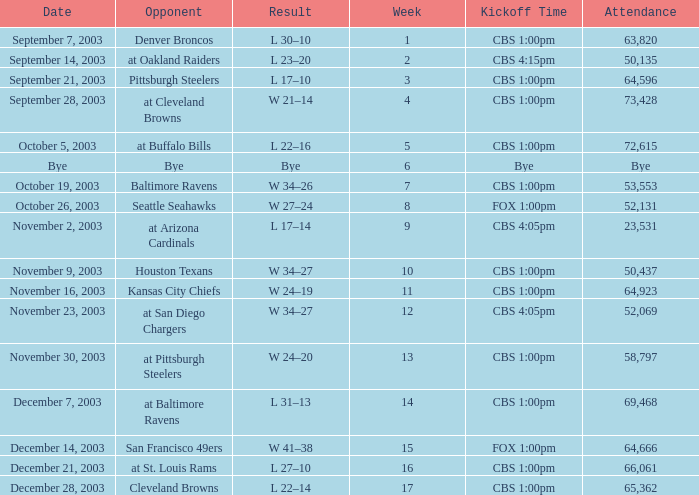What is the average number of weeks that the opponent was the Denver Broncos? 1.0. 